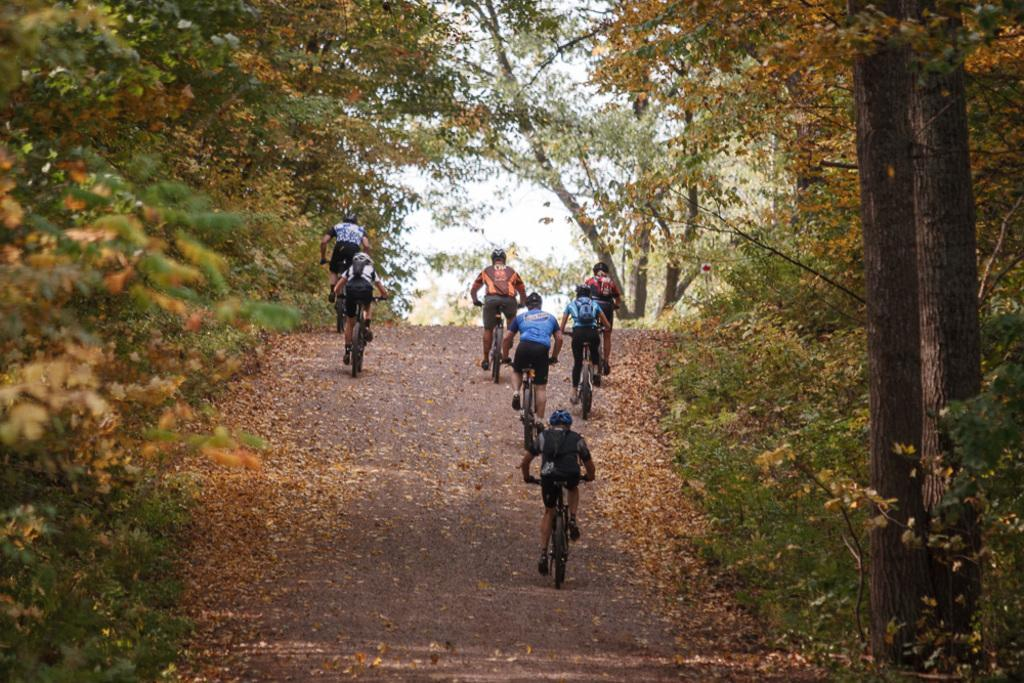What are the people in the image doing? The people in the image are riding bicycles. Where are the bicycles located? The bicycles are on a road. What can be seen in the background of the image? Trees and the sky are visible in the background. Can you tell if the image was taken during the day or night? The image is likely taken during the day, as the sky is visible and there is no indication of darkness. What type of ink is being used to write on the table in the image? There is no table or ink present in the image; it features a group of people riding bicycles on a road. What type of vehicle are the people driving in the image? The people are not driving a vehicle; they are riding bicycles. 